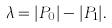Convert formula to latex. <formula><loc_0><loc_0><loc_500><loc_500>\lambda = | P _ { 0 } | - | P _ { 1 } | .</formula> 